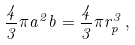Convert formula to latex. <formula><loc_0><loc_0><loc_500><loc_500>\frac { 4 } { 3 } \pi a ^ { 2 } b = \frac { 4 } { 3 } \pi r ^ { 3 } _ { p } \, ,</formula> 